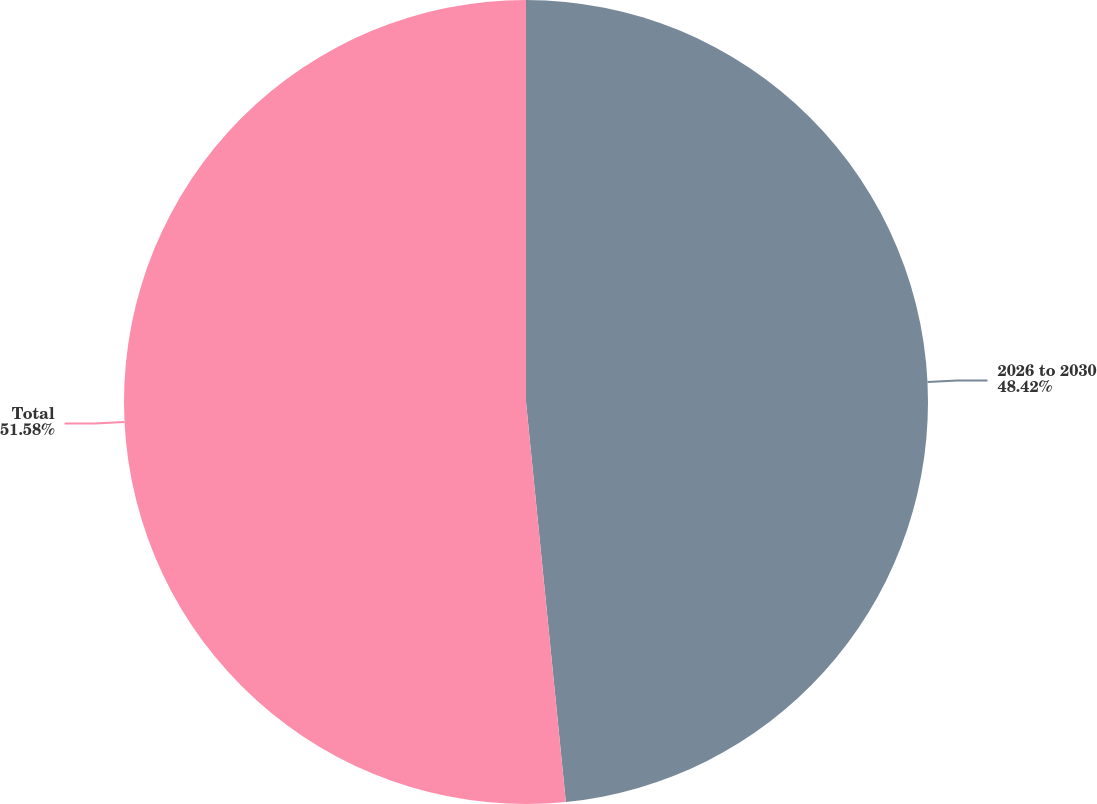Convert chart to OTSL. <chart><loc_0><loc_0><loc_500><loc_500><pie_chart><fcel>2026 to 2030<fcel>Total<nl><fcel>48.42%<fcel>51.58%<nl></chart> 